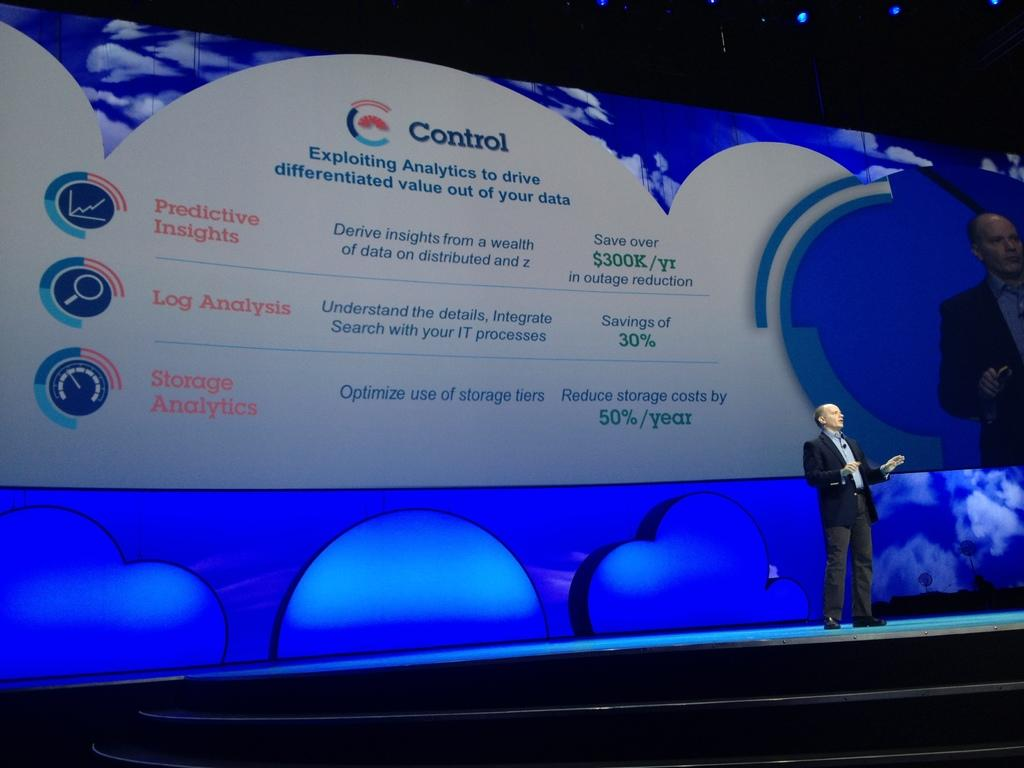<image>
Render a clear and concise summary of the photo. A presentation about making your data be more beneficial and profitable to you. 